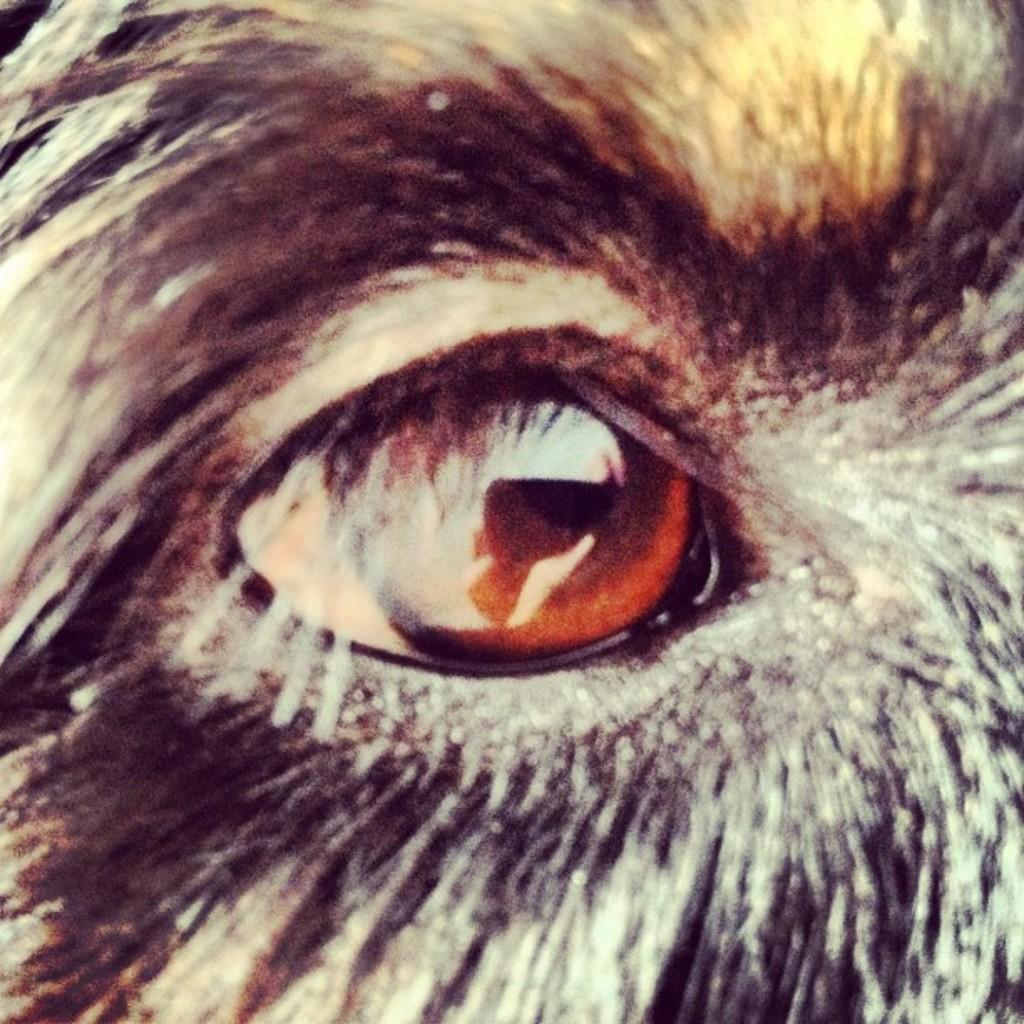What is the main subject of the image? The main subject of the image is an eye. What can be seen in the background or surrounding the eye? There is fur visible in the image. What time is displayed on the clock in the image? There is no clock present in the image. How many geese are visible in the image? There are no geese present in the image. 